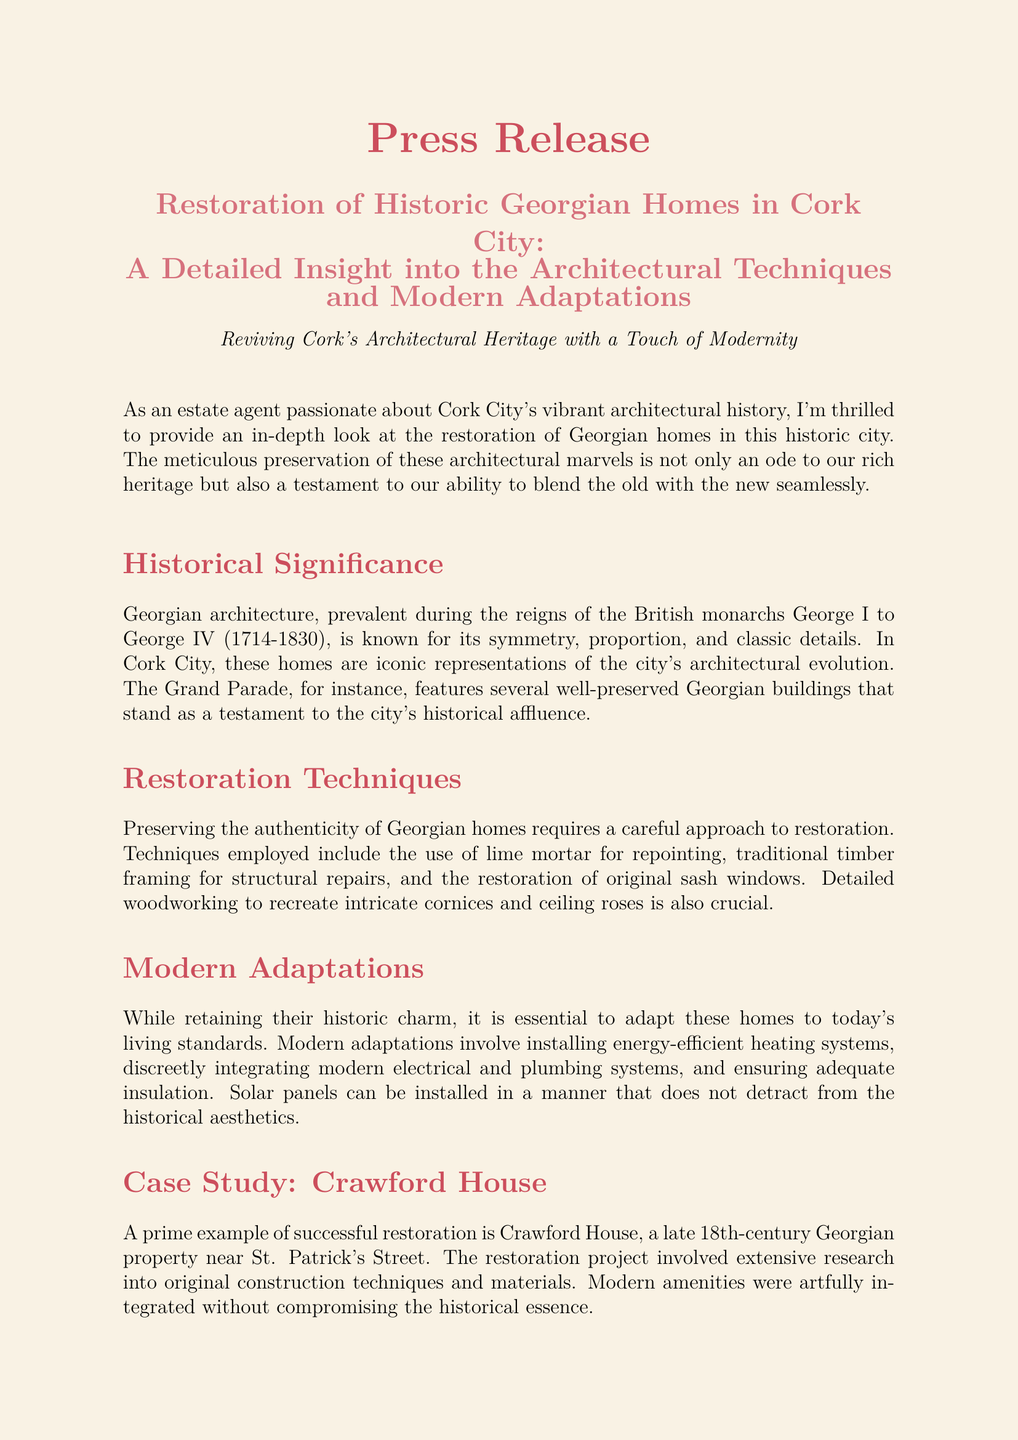what is the architectural period of Georgian homes? The document states that Georgian architecture was prevalent during the reigns of the British monarchs George I to George IV, specifically from 1714 to 1830.
Answer: 1714-1830 what is the name of the case study mentioned? The document highlights an example of a successful restoration project named Crawford House, which is a late 18th-century Georgian property.
Answer: Crawford House what is one traditional repair technique used in restoration? The document lists several techniques; one of them is the use of lime mortar for repointing.
Answer: lime mortar what type of heating systems are installed in restored homes? The document mentions the installation of energy-efficient heating systems as a modern adaptation.
Answer: energy-efficient what do local historical societies do? According to the document, local historical societies advocate for the preservation of Georgian homes, playing a pivotal role in their restoration.
Answer: advocate for preservation how does the restoration of homes benefit the community? The document suggests that workshops and forums on heritage conservation foster a community of knowledgeable advocates.
Answer: knowledge-sharing what is the main goal of modern adaptations in restored homes? The document indicates that the main goal is to adapt these homes to today's living standards while retaining historic charm.
Answer: adapt to modern standards what is the purpose of the Press Release? The purpose of the Press Release is to provide insight into the restoration of historic Georgian homes and promote architectural heritage preservation.
Answer: promote heritage preservation who can be contacted for more information? The document invites inquiries to be directed to "[Your Name]" at "[Your Contact Information]".
Answer: [Your Name] 